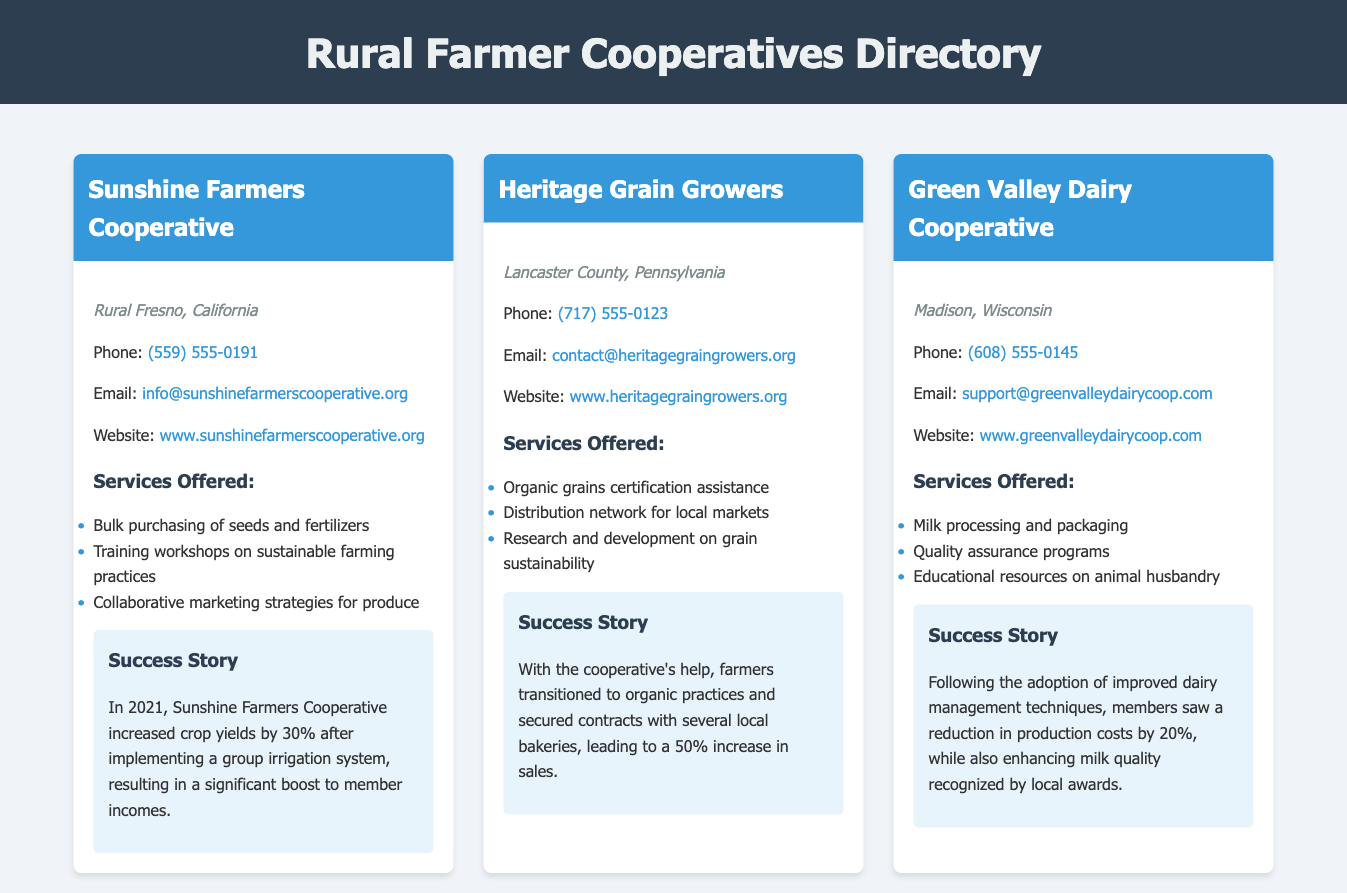What is the location of Sunshine Farmers Cooperative? Sunshine Farmers Cooperative is located in Rural Fresno, California, as stated in the coop-content section.
Answer: Rural Fresno, California What services does Heritage Grain Growers offer? The document lists three services offered by Heritage Grain Growers, which include organic grains certification assistance and more.
Answer: Organic grains certification assistance What was the crop yield increase for Sunshine Farmers Cooperative? The document mentions a specific percentage increase in crop yields due to the cooperative's efforts, specifically in 2021.
Answer: 30% What is the contact email for Green Valley Dairy Cooperative? The contact email is provided in the coop-contact section for Green Valley Dairy Cooperative.
Answer: support@greenvalleydairycoop.com What successful change did farmers achieve with Heritage Grain Growers? The information details a successful transition to organic practices and securing contracts with local businesses, showcasing the cooperative's impact.
Answer: 50% increase in sales How many cooperatives are mentioned in the document? The document specifically highlights three cooperatives, each with separate entries providing various details.
Answer: Three What is the success story related to Green Valley Dairy Cooperative? The success story details specific improvements and recognitions achieved by members after adopting new management techniques.
Answer: Reduction in production costs by 20% What is the phone number for Heritage Grain Growers? The document specifies the phone number in the coop-contact section for Heritage Grain Growers.
Answer: (717) 555-0123 What educational resources does Green Valley Dairy Cooperative provide? The document states that educational resources on animal husbandry are among the services offered by the cooperative.
Answer: Educational resources on animal husbandry 